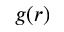Convert formula to latex. <formula><loc_0><loc_0><loc_500><loc_500>g ( r )</formula> 